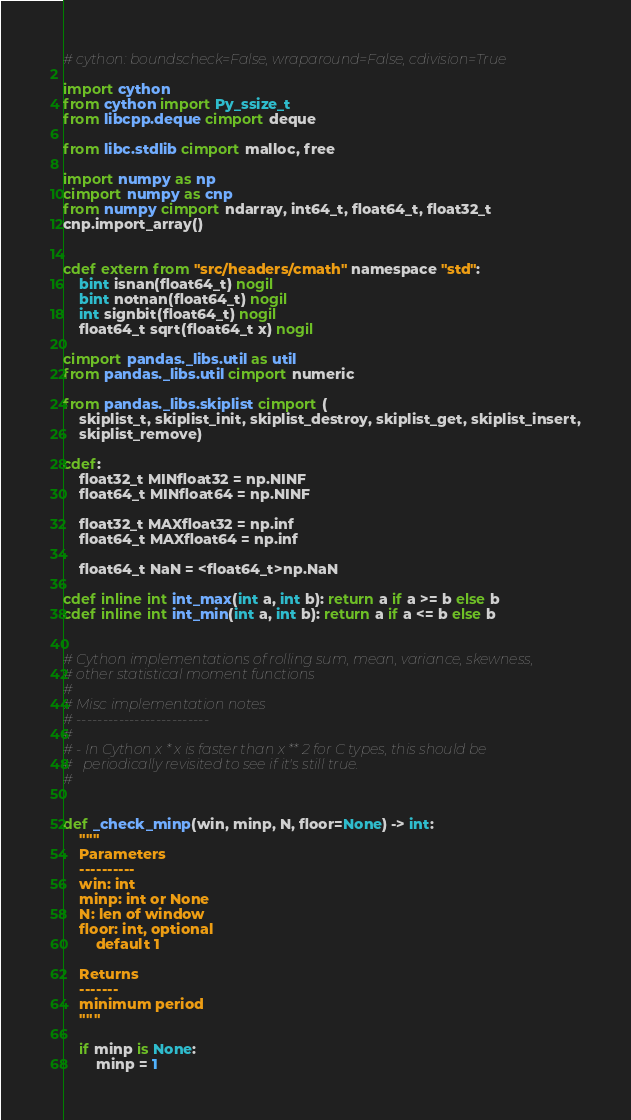<code> <loc_0><loc_0><loc_500><loc_500><_Cython_># cython: boundscheck=False, wraparound=False, cdivision=True

import cython
from cython import Py_ssize_t
from libcpp.deque cimport deque

from libc.stdlib cimport malloc, free

import numpy as np
cimport numpy as cnp
from numpy cimport ndarray, int64_t, float64_t, float32_t
cnp.import_array()


cdef extern from "src/headers/cmath" namespace "std":
    bint isnan(float64_t) nogil
    bint notnan(float64_t) nogil
    int signbit(float64_t) nogil
    float64_t sqrt(float64_t x) nogil

cimport pandas._libs.util as util
from pandas._libs.util cimport numeric

from pandas._libs.skiplist cimport (
    skiplist_t, skiplist_init, skiplist_destroy, skiplist_get, skiplist_insert,
    skiplist_remove)

cdef:
    float32_t MINfloat32 = np.NINF
    float64_t MINfloat64 = np.NINF

    float32_t MAXfloat32 = np.inf
    float64_t MAXfloat64 = np.inf

    float64_t NaN = <float64_t>np.NaN

cdef inline int int_max(int a, int b): return a if a >= b else b
cdef inline int int_min(int a, int b): return a if a <= b else b


# Cython implementations of rolling sum, mean, variance, skewness,
# other statistical moment functions
#
# Misc implementation notes
# -------------------------
#
# - In Cython x * x is faster than x ** 2 for C types, this should be
#   periodically revisited to see if it's still true.
#


def _check_minp(win, minp, N, floor=None) -> int:
    """
    Parameters
    ----------
    win: int
    minp: int or None
    N: len of window
    floor: int, optional
        default 1

    Returns
    -------
    minimum period
    """

    if minp is None:
        minp = 1</code> 